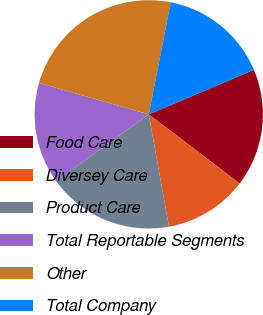<chart> <loc_0><loc_0><loc_500><loc_500><pie_chart><fcel>Food Care<fcel>Diversey Care<fcel>Product Care<fcel>Total Reportable Segments<fcel>Other<fcel>Total Company<nl><fcel>16.72%<fcel>11.82%<fcel>17.91%<fcel>14.36%<fcel>23.65%<fcel>15.54%<nl></chart> 